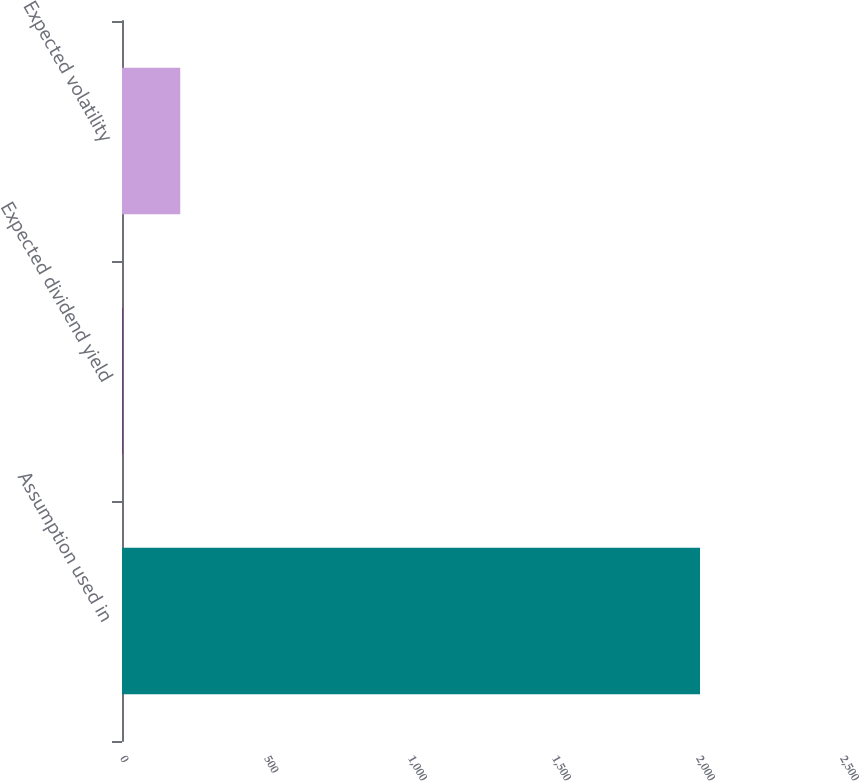<chart> <loc_0><loc_0><loc_500><loc_500><bar_chart><fcel>Assumption used in<fcel>Expected dividend yield<fcel>Expected volatility<nl><fcel>2007<fcel>1.72<fcel>202.25<nl></chart> 